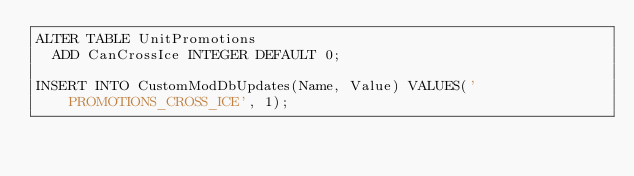<code> <loc_0><loc_0><loc_500><loc_500><_SQL_>ALTER TABLE UnitPromotions
  ADD CanCrossIce INTEGER DEFAULT 0;

INSERT INTO CustomModDbUpdates(Name, Value) VALUES('PROMOTIONS_CROSS_ICE', 1);
</code> 